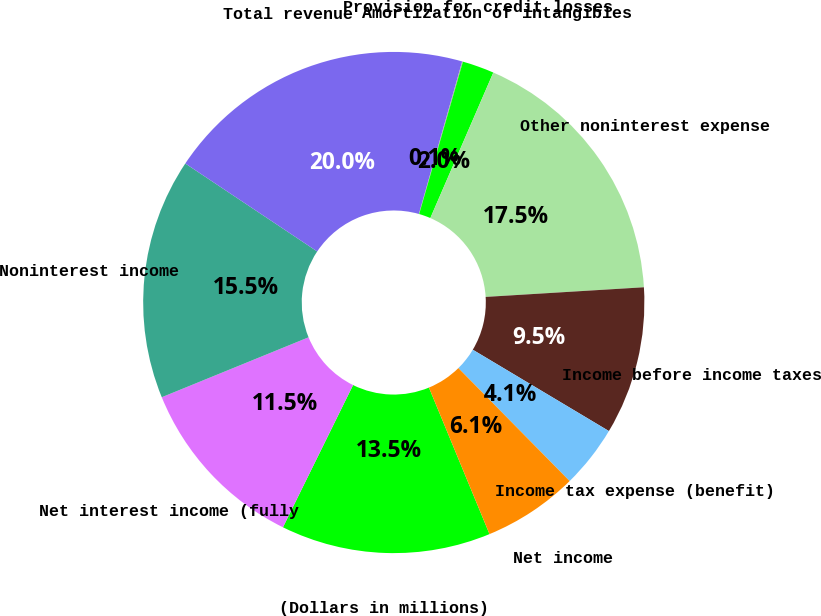Convert chart. <chart><loc_0><loc_0><loc_500><loc_500><pie_chart><fcel>(Dollars in millions)<fcel>Net interest income (fully<fcel>Noninterest income<fcel>Total revenue<fcel>Provision for credit losses<fcel>Amortization of intangibles<fcel>Other noninterest expense<fcel>Income before income taxes<fcel>Income tax expense (benefit)<fcel>Net income<nl><fcel>13.53%<fcel>11.54%<fcel>15.53%<fcel>20.04%<fcel>0.05%<fcel>2.05%<fcel>17.53%<fcel>9.54%<fcel>4.05%<fcel>6.14%<nl></chart> 